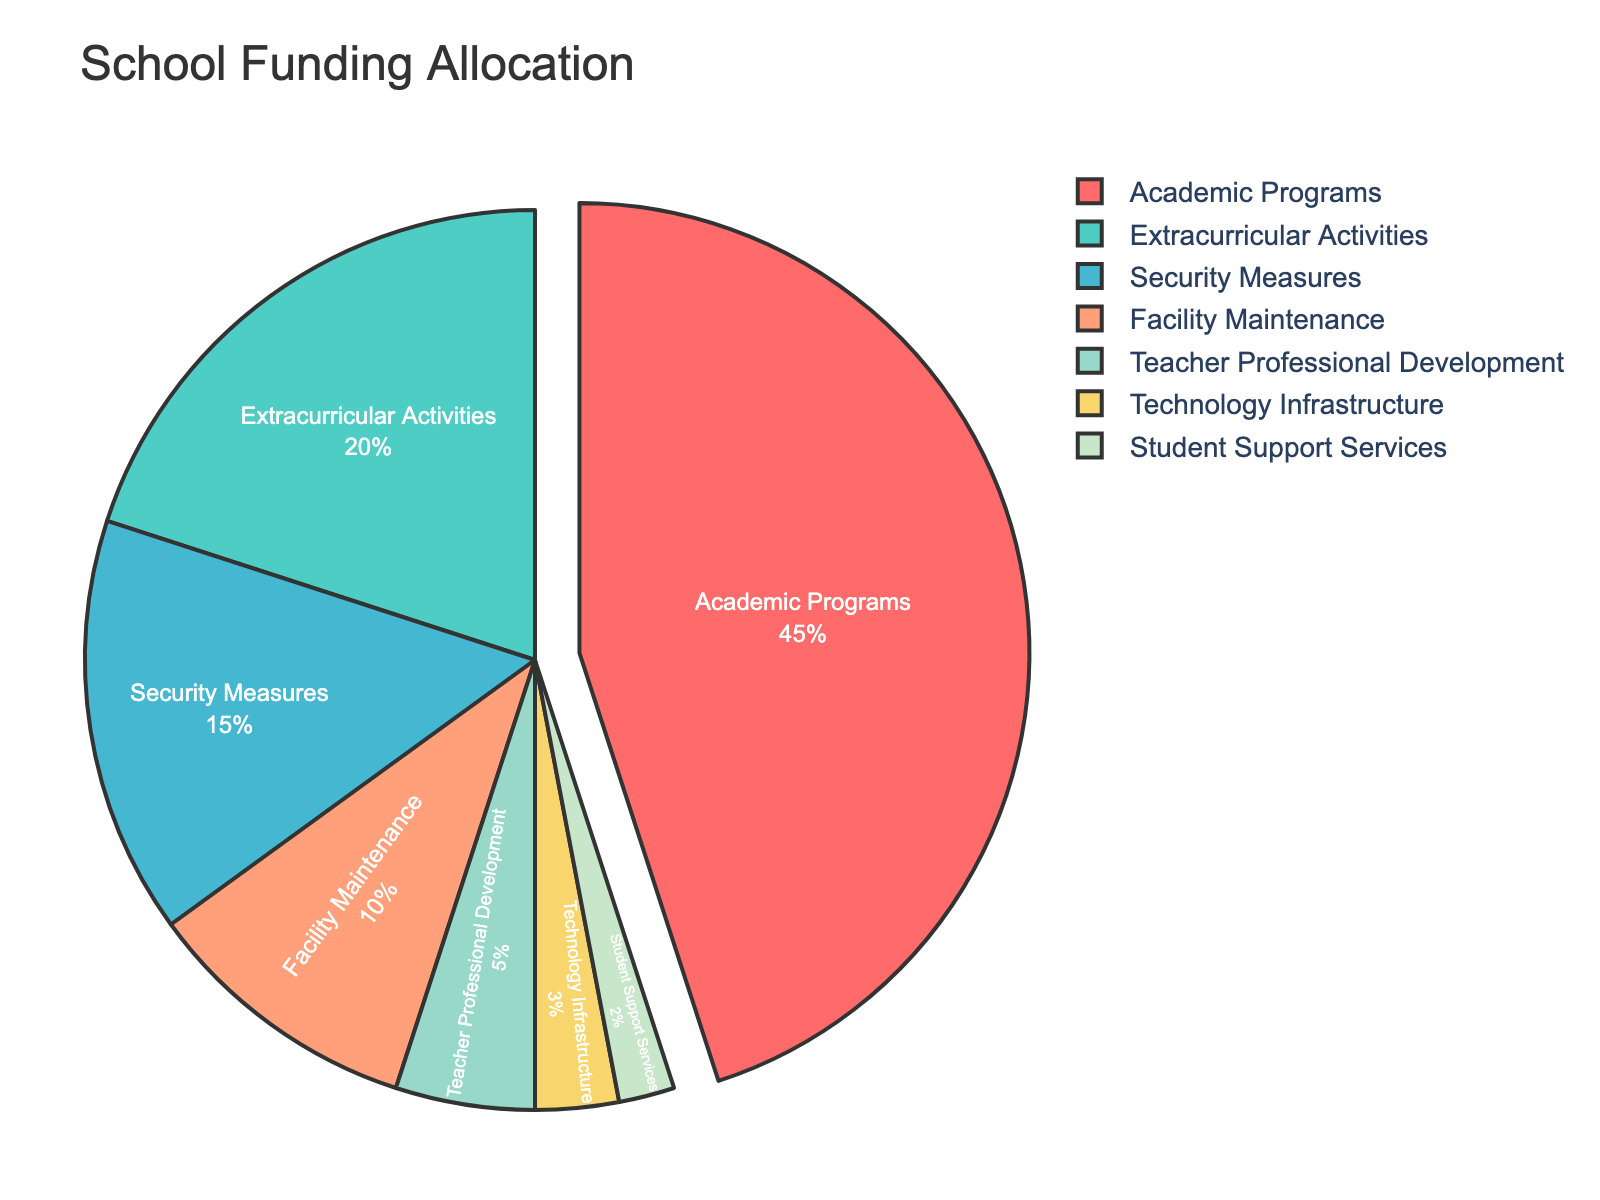Which category receives the highest percentage of school funding? The pie chart shows different categories of school funding allocation with their respective percentages. The largest segment in the pie chart represents Academic Programs with 45%.
Answer: Academic Programs What is the combined percentage of funding allocated to Technology Infrastructure and Student Support Services? The percentages for Technology Infrastructure and Student Support Services are 3% and 2% respectively. Adding them together gives 3% + 2% = 5%.
Answer: 5% Which is greater: the funding for Extracurricular Activities or Security Measures? The pie chart shows that Extracurricular Activities receive 20% and Security Measures receive 15%. Since 20% is greater than 15%, Extracurricular Activities receive more funding.
Answer: Extracurricular Activities What is the difference between the funding for Academic Programs and Facility Maintenance? Academic Programs receive 45% of the funding, while Facility Maintenance receives 10%. The difference is 45% - 10% = 35%.
Answer: 35% What percentage of funding is allocated to Teacher Professional Development, Technology Infrastructure, and Student Support Services combined? The percentages for Teacher Professional Development, Technology Infrastructure, and Student Support Services are 5%, 3%, and 2% respectively. Adding them together gives 5% + 3% + 2% = 10%.
Answer: 10% How does the funding for Security Measures compare visually to that for Technology Infrastructure? The Security Measures segment is notably larger than the Technology Infrastructure segment in the pie chart. This visual difference confirms that Security Measures receive a higher percentage (15% vs. 3%).
Answer: Security Measures receive more Are there more funds allocated to Extracurricular Activities or Facility Maintenance? The pie chart shows that Extracurricular Activities receive 20% of the funds, whereas Facility Maintenance receives 10%. Therefore, Extracurricular Activities get more funding.
Answer: Extracurricular Activities Is the total funding for Security Measures and Facility Maintenance more or less than the funding for Academic Programs? Security Measures have 15% and Facility Maintenance has 10%. Combined, they total 15% + 10% = 25%. Since Academic Programs get 45%, the funding for Security Measures and Facility Maintenance combined is less than for Academic Programs.
Answer: Less What is the smallest allocation category in school funding? The pie chart shows the different percentages for each category. The smallest slice represents Student Support Services with 2%.
Answer: Student Support Services 